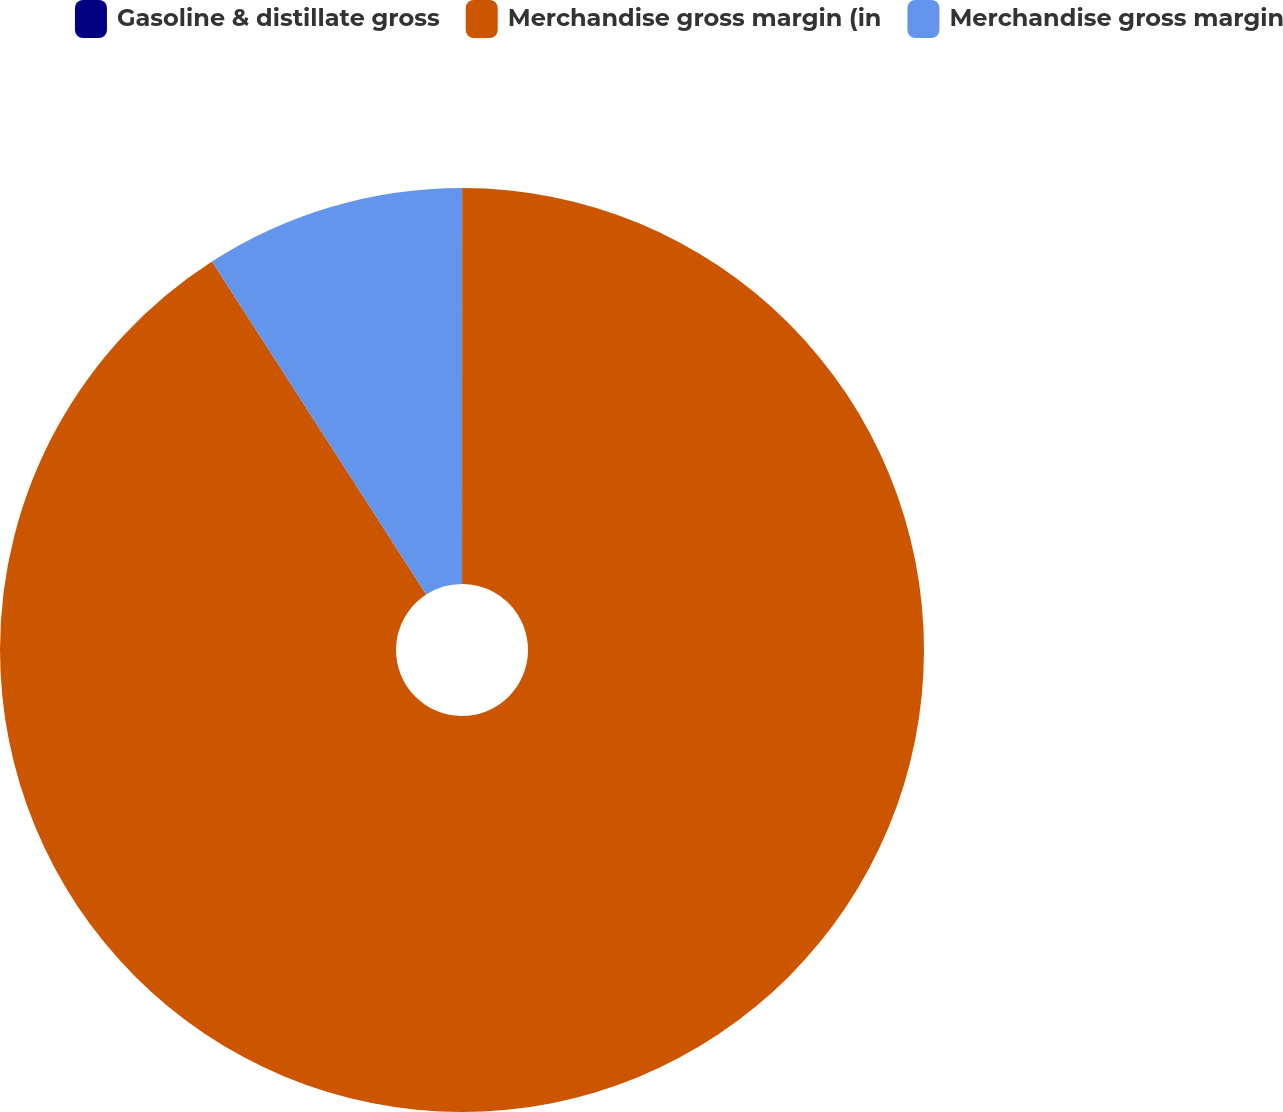Convert chart. <chart><loc_0><loc_0><loc_500><loc_500><pie_chart><fcel>Gasoline & distillate gross<fcel>Merchandise gross margin (in<fcel>Merchandise gross margin<nl><fcel>0.01%<fcel>90.89%<fcel>9.1%<nl></chart> 